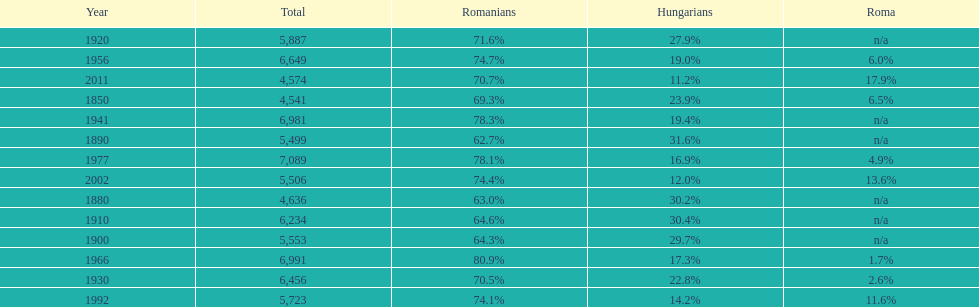In what year was there the largest percentage of hungarians? 1890. 